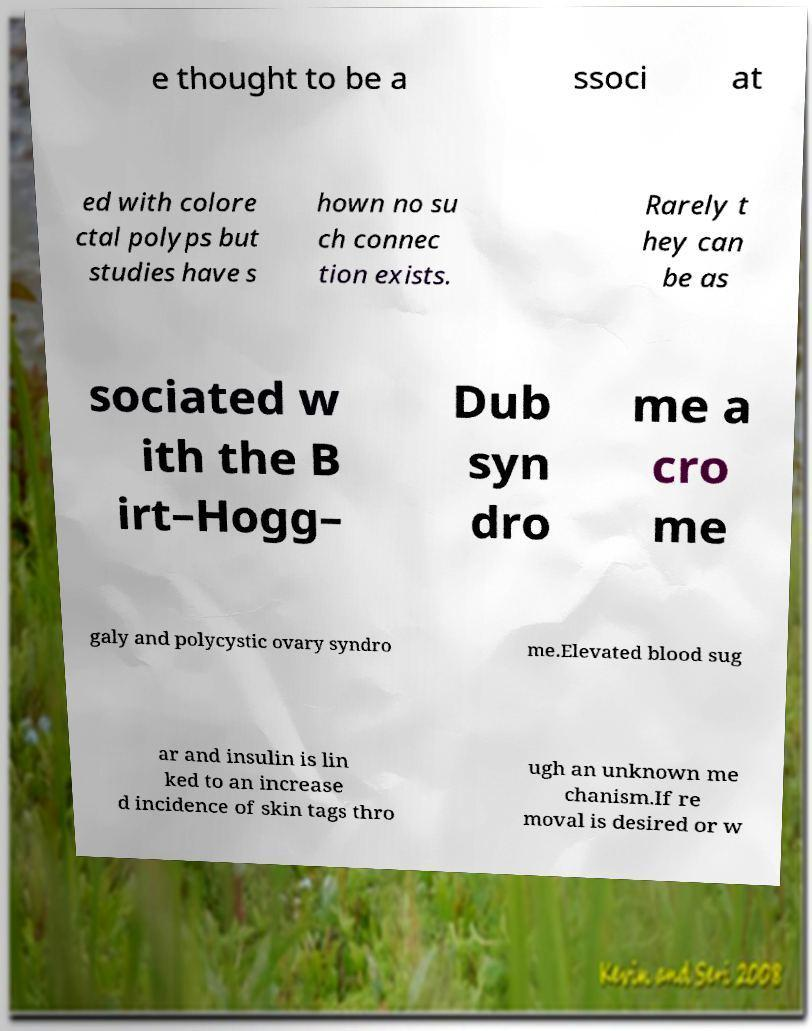Can you read and provide the text displayed in the image?This photo seems to have some interesting text. Can you extract and type it out for me? e thought to be a ssoci at ed with colore ctal polyps but studies have s hown no su ch connec tion exists. Rarely t hey can be as sociated w ith the B irt–Hogg– Dub syn dro me a cro me galy and polycystic ovary syndro me.Elevated blood sug ar and insulin is lin ked to an increase d incidence of skin tags thro ugh an unknown me chanism.If re moval is desired or w 